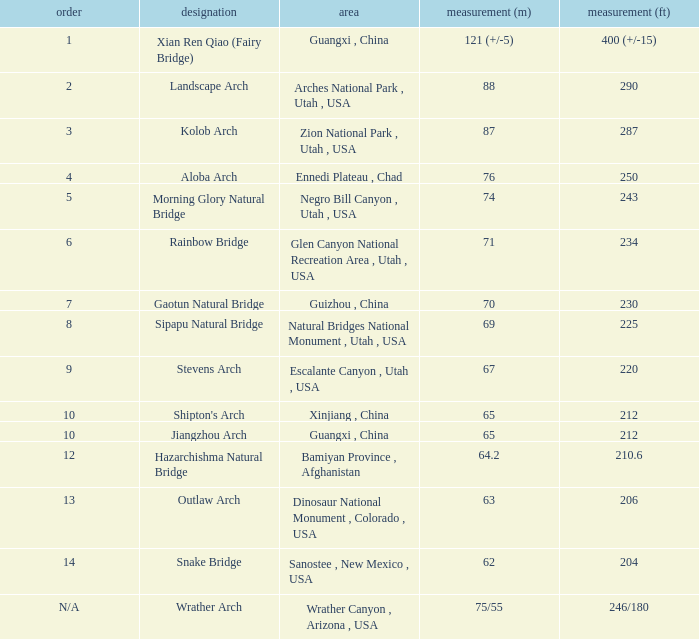Where is the longest arch with a length in meters of 64.2? Bamiyan Province , Afghanistan. 